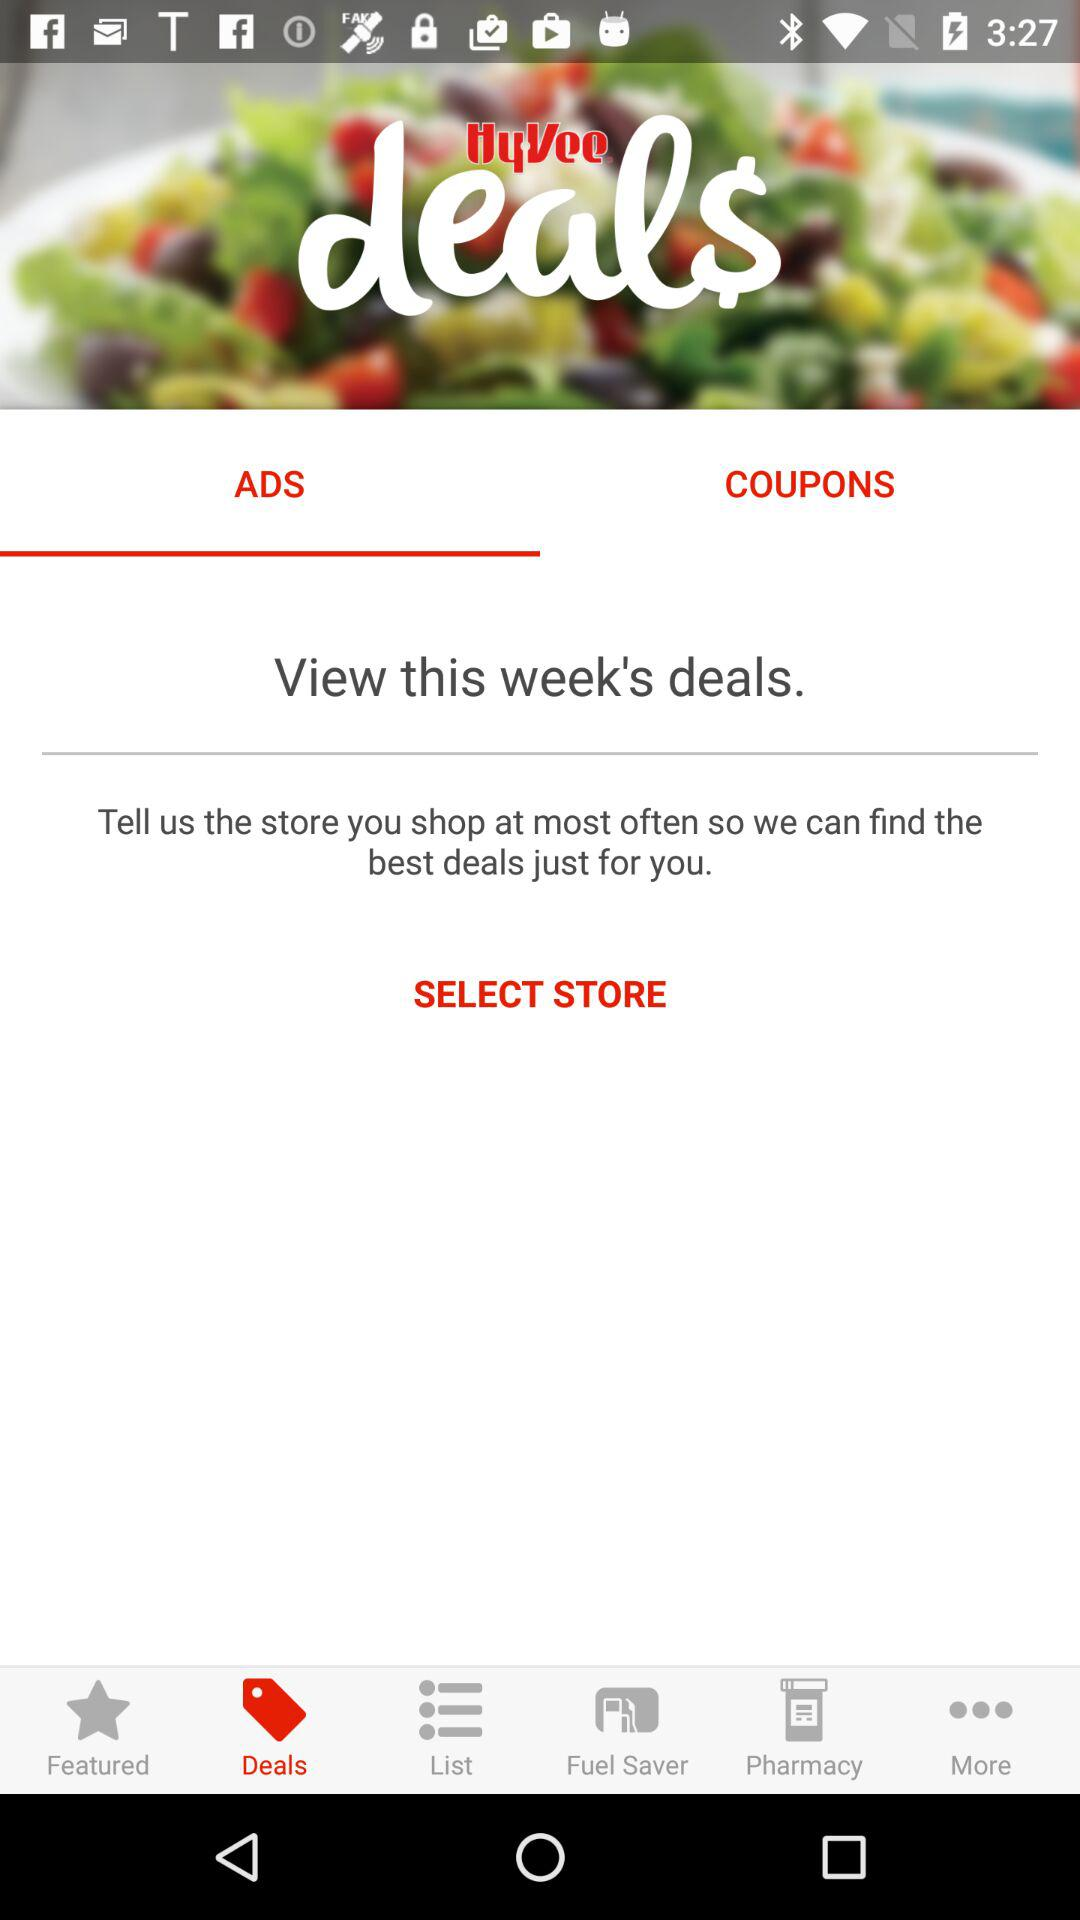What is the application name? The application name is "Hy-Vee". 